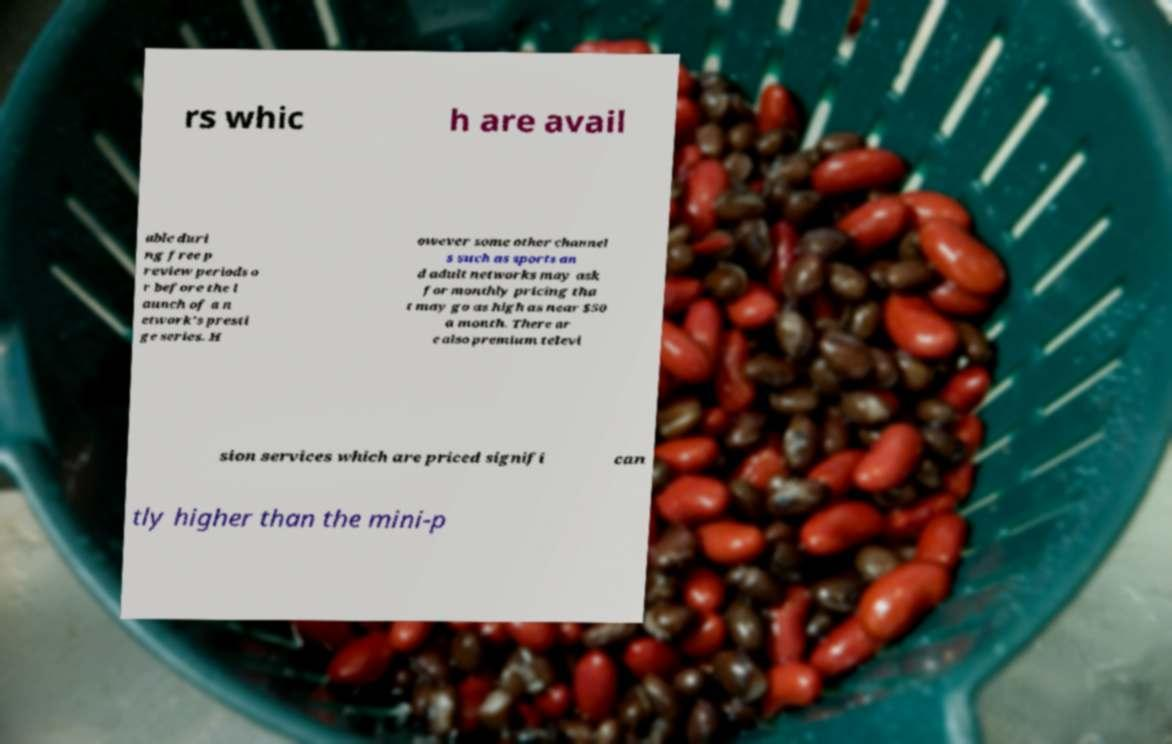I need the written content from this picture converted into text. Can you do that? rs whic h are avail able duri ng free p review periods o r before the l aunch of a n etwork's presti ge series. H owever some other channel s such as sports an d adult networks may ask for monthly pricing tha t may go as high as near $50 a month. There ar e also premium televi sion services which are priced signifi can tly higher than the mini-p 